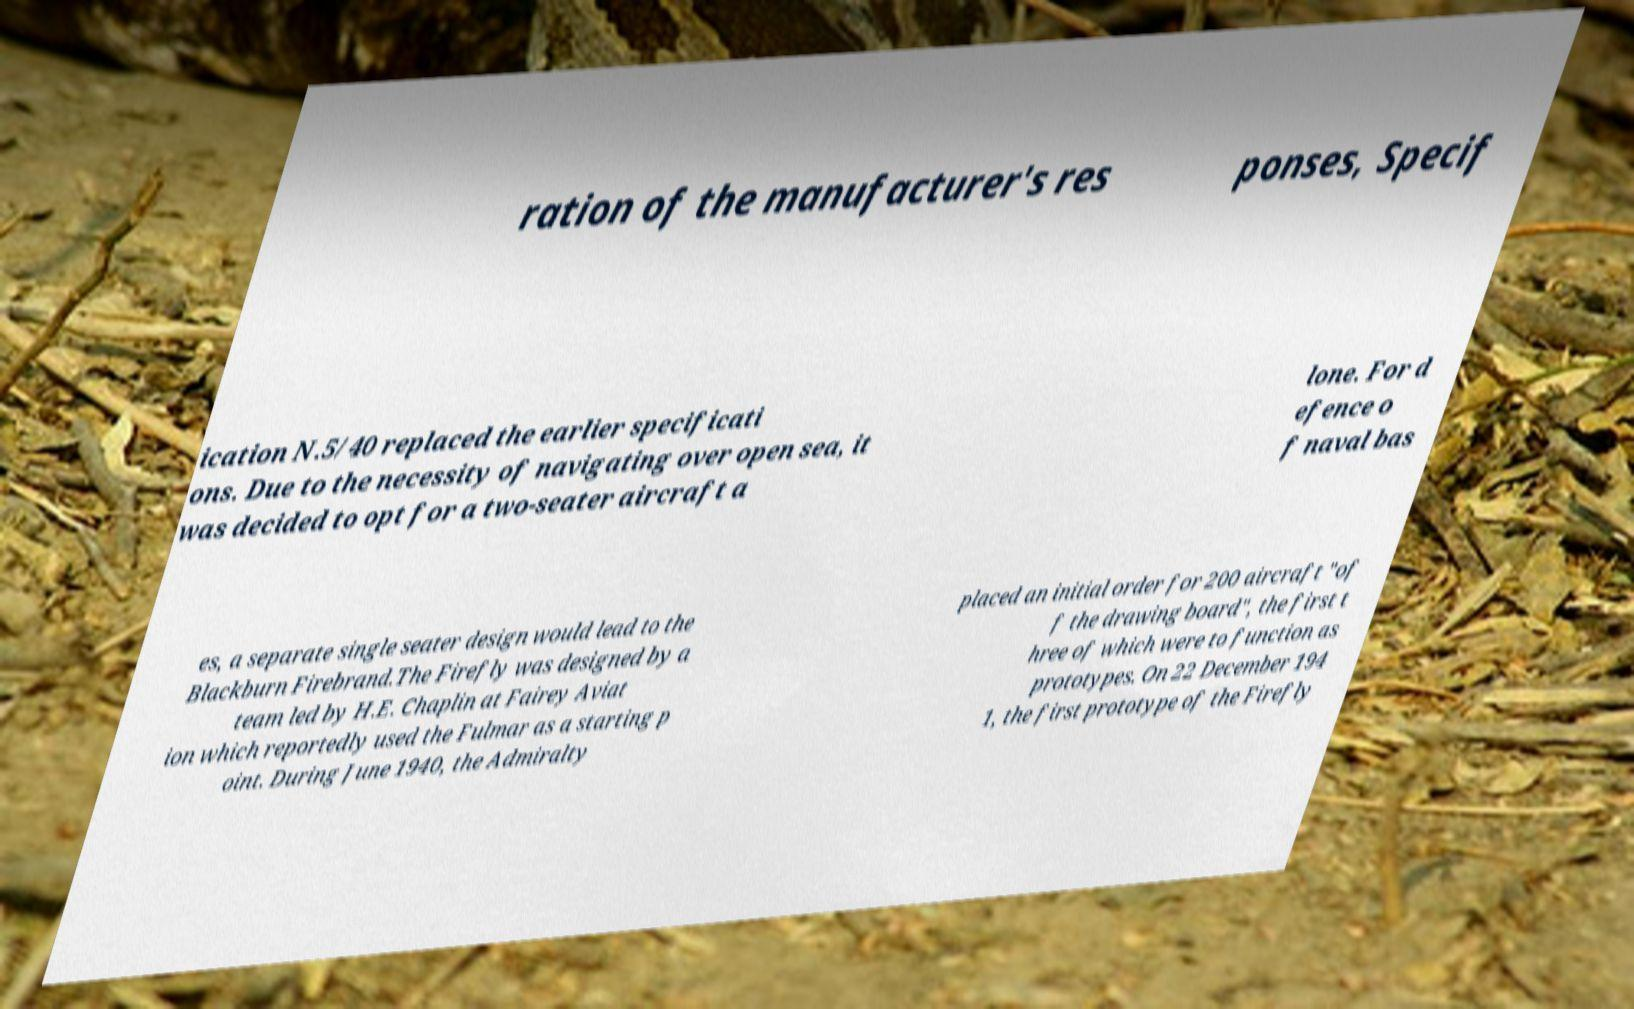Please identify and transcribe the text found in this image. ration of the manufacturer's res ponses, Specif ication N.5/40 replaced the earlier specificati ons. Due to the necessity of navigating over open sea, it was decided to opt for a two-seater aircraft a lone. For d efence o f naval bas es, a separate single seater design would lead to the Blackburn Firebrand.The Firefly was designed by a team led by H.E. Chaplin at Fairey Aviat ion which reportedly used the Fulmar as a starting p oint. During June 1940, the Admiralty placed an initial order for 200 aircraft "of f the drawing board", the first t hree of which were to function as prototypes. On 22 December 194 1, the first prototype of the Firefly 